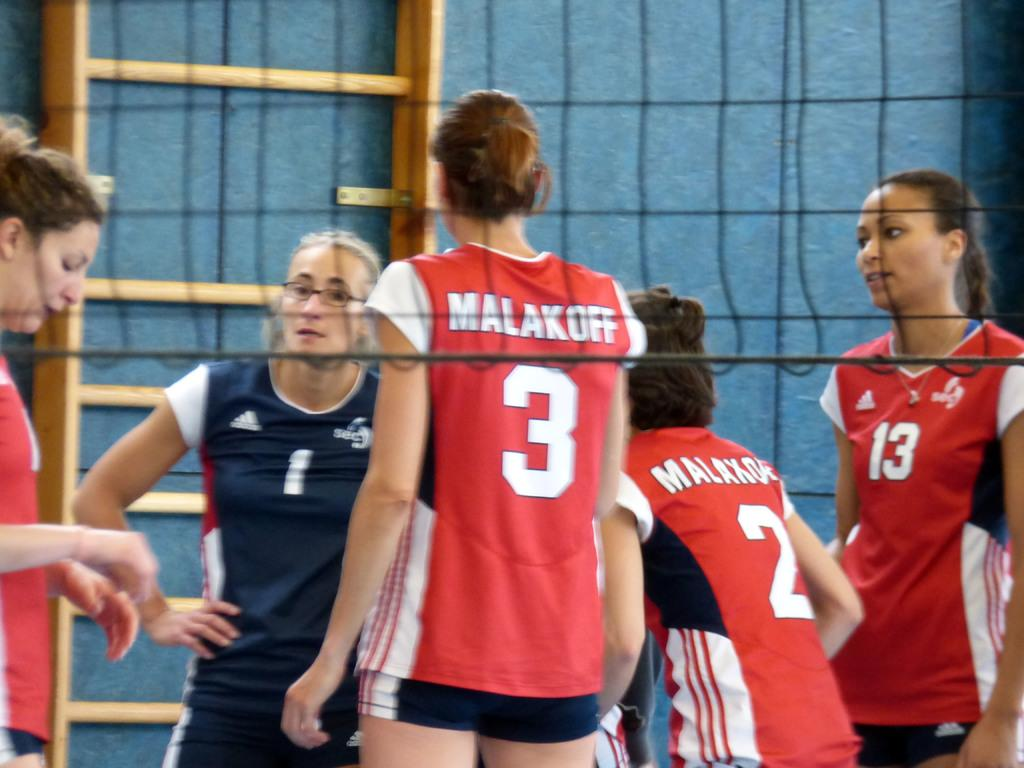How many women are in the image? There are women in the image, but the exact number is not specified. What are the women doing in the image? The women are standing in the image. How many bikes are being ridden by the women in the image? There is no mention of bikes or any activity involving bikes in the image. 